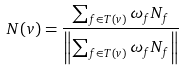Convert formula to latex. <formula><loc_0><loc_0><loc_500><loc_500>N ( v ) = \frac { \sum _ { f \in T ( v ) } \omega _ { f } N _ { f } } { \left \| \sum _ { f \in T ( v ) } \omega _ { f } N _ { f } \right \| }</formula> 